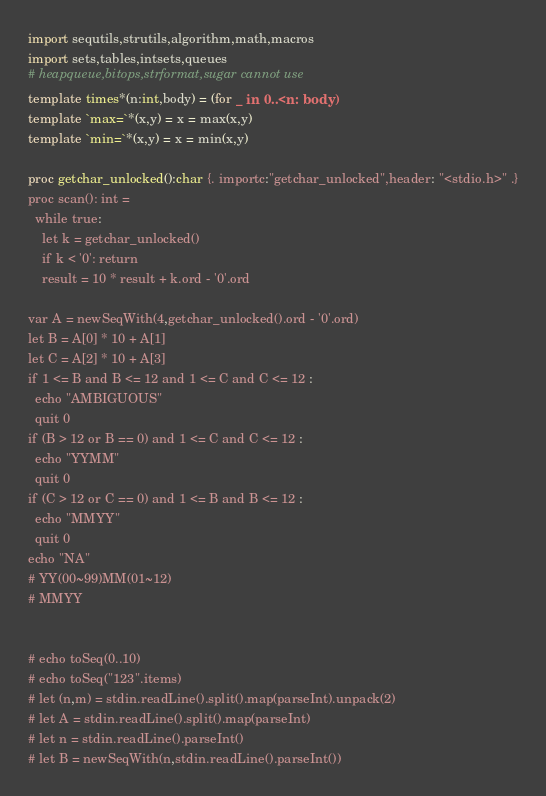<code> <loc_0><loc_0><loc_500><loc_500><_Nim_>import sequtils,strutils,algorithm,math,macros
import sets,tables,intsets,queues
# heapqueue,bitops,strformat,sugar cannot use
template times*(n:int,body) = (for _ in 0..<n: body)
template `max=`*(x,y) = x = max(x,y)
template `min=`*(x,y) = x = min(x,y)

proc getchar_unlocked():char {. importc:"getchar_unlocked",header: "<stdio.h>" .}
proc scan(): int =
  while true:
    let k = getchar_unlocked()
    if k < '0': return
    result = 10 * result + k.ord - '0'.ord

var A = newSeqWith(4,getchar_unlocked().ord - '0'.ord)
let B = A[0] * 10 + A[1]
let C = A[2] * 10 + A[3]
if 1 <= B and B <= 12 and 1 <= C and C <= 12 :
  echo "AMBIGUOUS"
  quit 0
if (B > 12 or B == 0) and 1 <= C and C <= 12 :
  echo "YYMM"
  quit 0
if (C > 12 or C == 0) and 1 <= B and B <= 12 :
  echo "MMYY"
  quit 0
echo "NA"
# YY(00~99)MM(01~12)
# MMYY


# echo toSeq(0..10)
# echo toSeq("123".items)
# let (n,m) = stdin.readLine().split().map(parseInt).unpack(2)
# let A = stdin.readLine().split().map(parseInt)
# let n = stdin.readLine().parseInt()
# let B = newSeqWith(n,stdin.readLine().parseInt())
</code> 